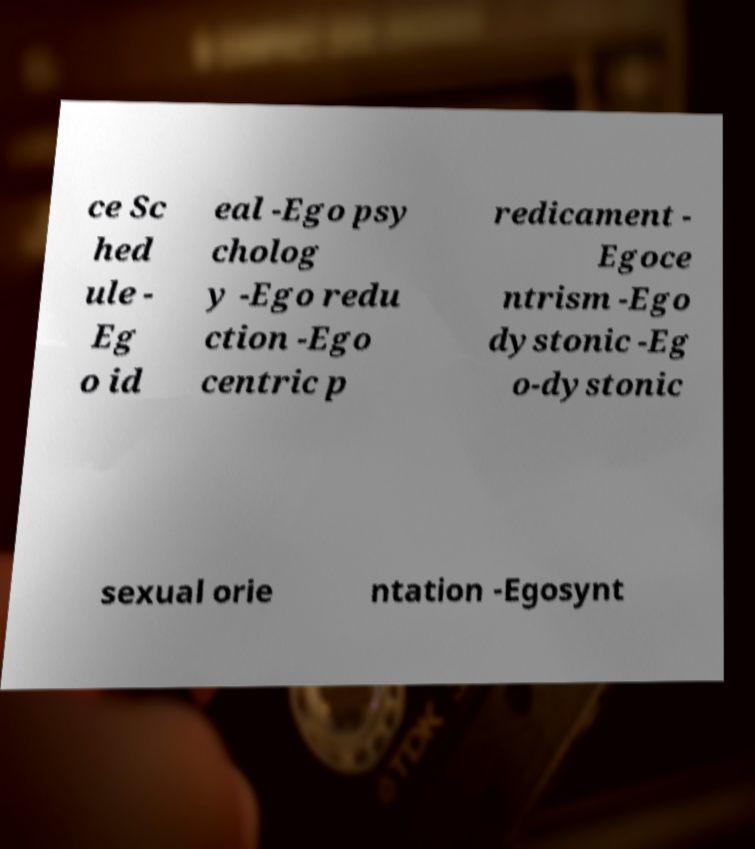Can you read and provide the text displayed in the image?This photo seems to have some interesting text. Can you extract and type it out for me? ce Sc hed ule - Eg o id eal -Ego psy cholog y -Ego redu ction -Ego centric p redicament - Egoce ntrism -Ego dystonic -Eg o-dystonic sexual orie ntation -Egosynt 